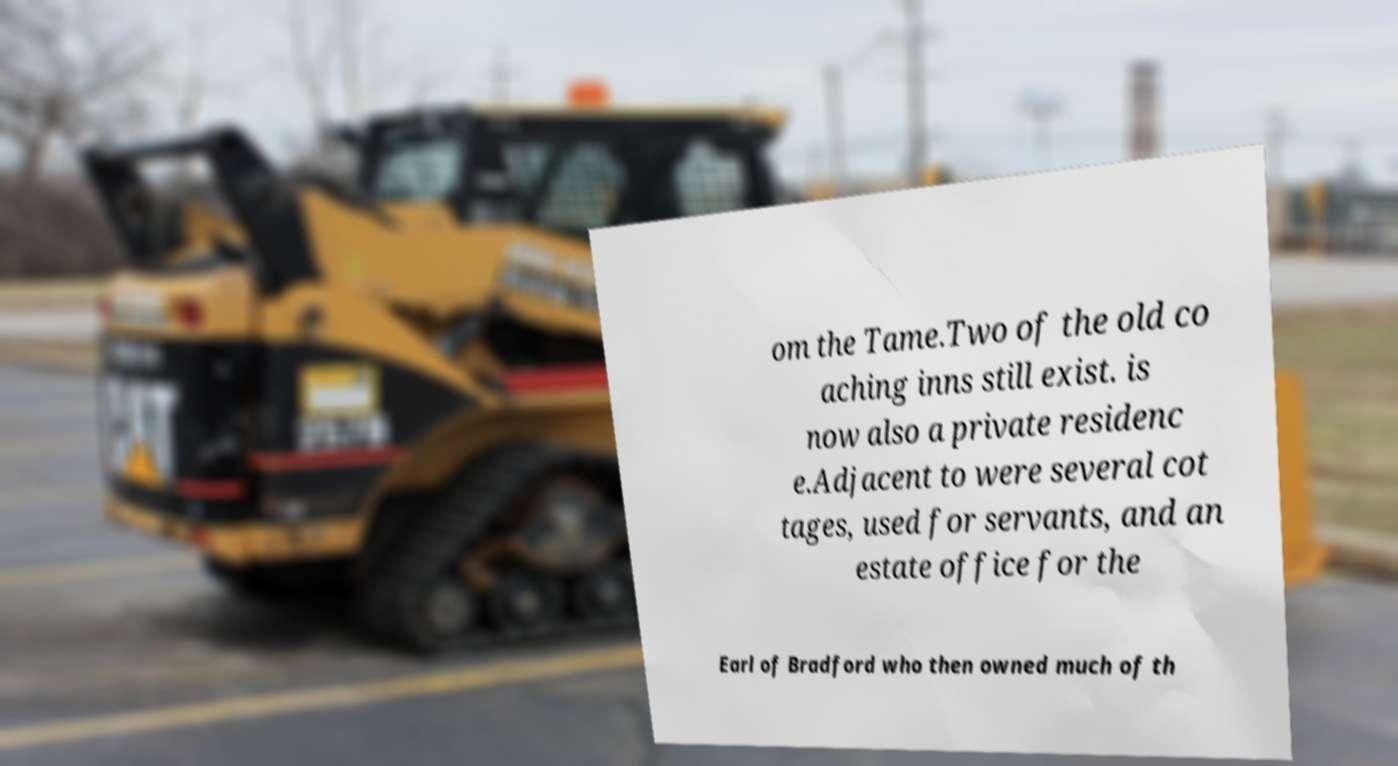Please identify and transcribe the text found in this image. om the Tame.Two of the old co aching inns still exist. is now also a private residenc e.Adjacent to were several cot tages, used for servants, and an estate office for the Earl of Bradford who then owned much of th 